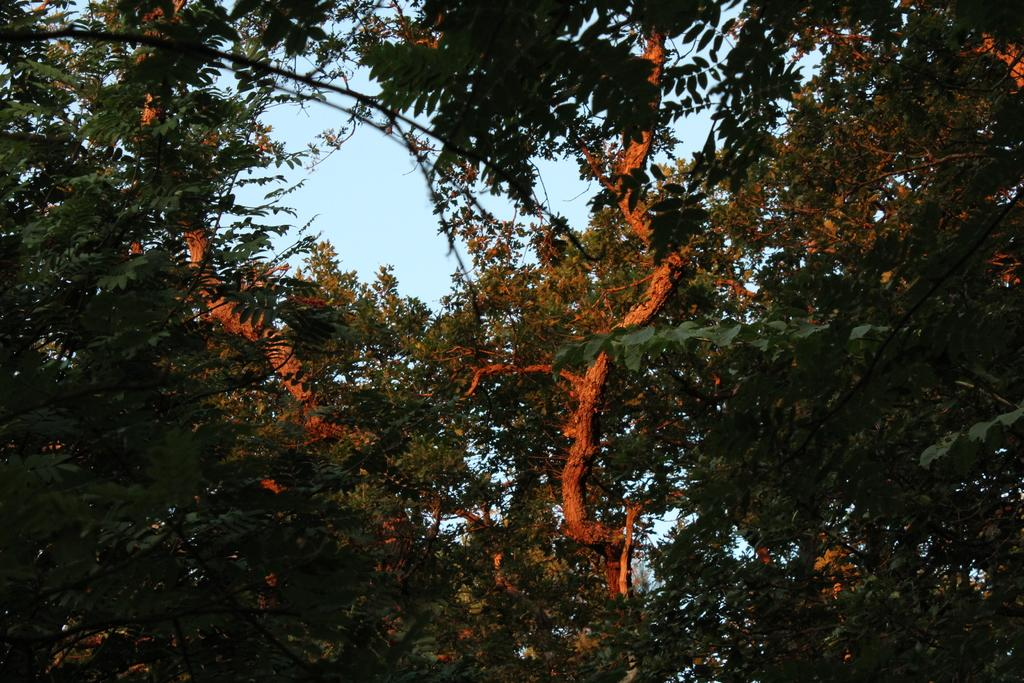What type of vegetation can be seen in the image? There are trees in the image. What is the color of the leaves on the trees? The trees have green leaves. What can be seen in the background of the image? The sky is visible in the background of the image. What is the color of the sky in the image? The sky is blue in color. How many cows are grazing under the trees in the image? There are no cows present in the image; it only features trees and a blue sky. What type of twig can be seen falling from the trees in the image? There is no twig falling from the trees in the image. 